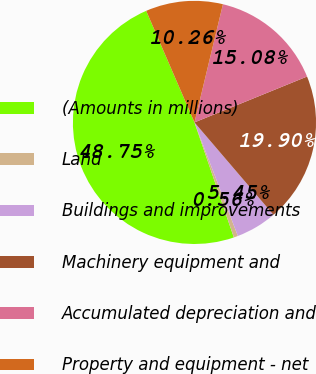<chart> <loc_0><loc_0><loc_500><loc_500><pie_chart><fcel>(Amounts in millions)<fcel>Land<fcel>Buildings and improvements<fcel>Machinery equipment and<fcel>Accumulated depreciation and<fcel>Property and equipment - net<nl><fcel>48.75%<fcel>0.56%<fcel>5.45%<fcel>19.9%<fcel>15.08%<fcel>10.26%<nl></chart> 